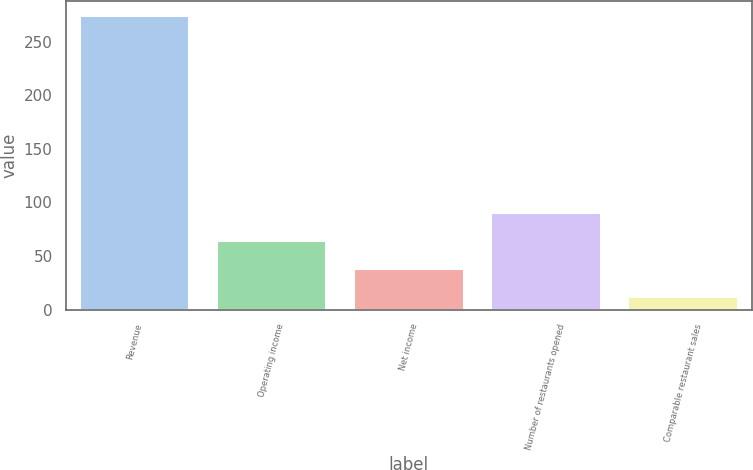Convert chart to OTSL. <chart><loc_0><loc_0><loc_500><loc_500><bar_chart><fcel>Revenue<fcel>Operating income<fcel>Net income<fcel>Number of restaurants opened<fcel>Comparable restaurant sales<nl><fcel>274.3<fcel>64.14<fcel>37.87<fcel>90.41<fcel>11.6<nl></chart> 